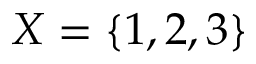Convert formula to latex. <formula><loc_0><loc_0><loc_500><loc_500>X = \{ 1 , 2 , 3 \}</formula> 